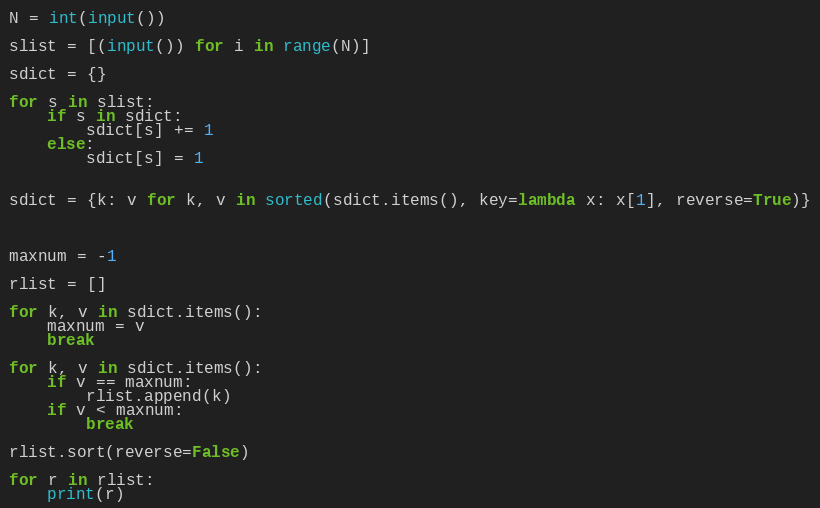Convert code to text. <code><loc_0><loc_0><loc_500><loc_500><_Python_>N = int(input())

slist = [(input()) for i in range(N)]

sdict = {}

for s in slist:
    if s in sdict:
        sdict[s] += 1
    else:
        sdict[s] = 1


sdict = {k: v for k, v in sorted(sdict.items(), key=lambda x: x[1], reverse=True)}



maxnum = -1

rlist = []

for k, v in sdict.items():
    maxnum = v
    break

for k, v in sdict.items():
    if v == maxnum:
        rlist.append(k)
    if v < maxnum:
        break

rlist.sort(reverse=False)

for r in rlist:
    print(r)

</code> 